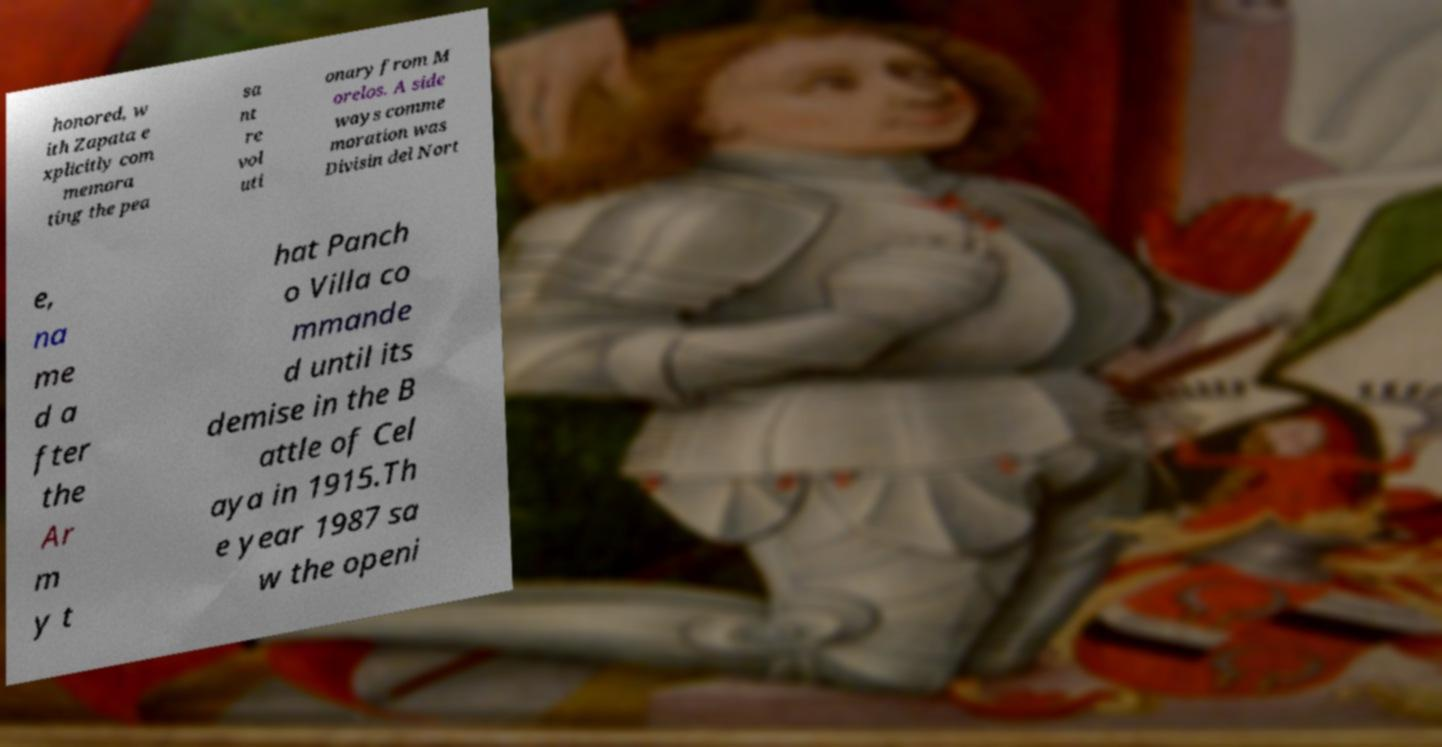I need the written content from this picture converted into text. Can you do that? honored, w ith Zapata e xplicitly com memora ting the pea sa nt re vol uti onary from M orelos. A side ways comme moration was Divisin del Nort e, na me d a fter the Ar m y t hat Panch o Villa co mmande d until its demise in the B attle of Cel aya in 1915.Th e year 1987 sa w the openi 